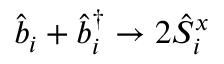<formula> <loc_0><loc_0><loc_500><loc_500>\hat { b } _ { i } + \hat { b } _ { i } ^ { \dagger } \rightarrow 2 \hat { S } _ { i } ^ { x }</formula> 